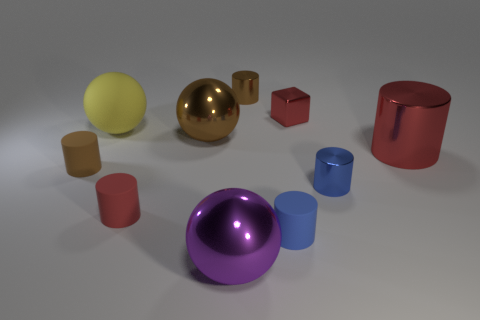Subtract all red cylinders. How many cylinders are left? 4 Subtract all small blue matte cylinders. How many cylinders are left? 5 Subtract all cyan cylinders. Subtract all yellow balls. How many cylinders are left? 6 Subtract all blocks. How many objects are left? 9 Subtract 0 green blocks. How many objects are left? 10 Subtract all large purple metal spheres. Subtract all blue rubber objects. How many objects are left? 8 Add 7 brown shiny objects. How many brown shiny objects are left? 9 Add 5 yellow objects. How many yellow objects exist? 6 